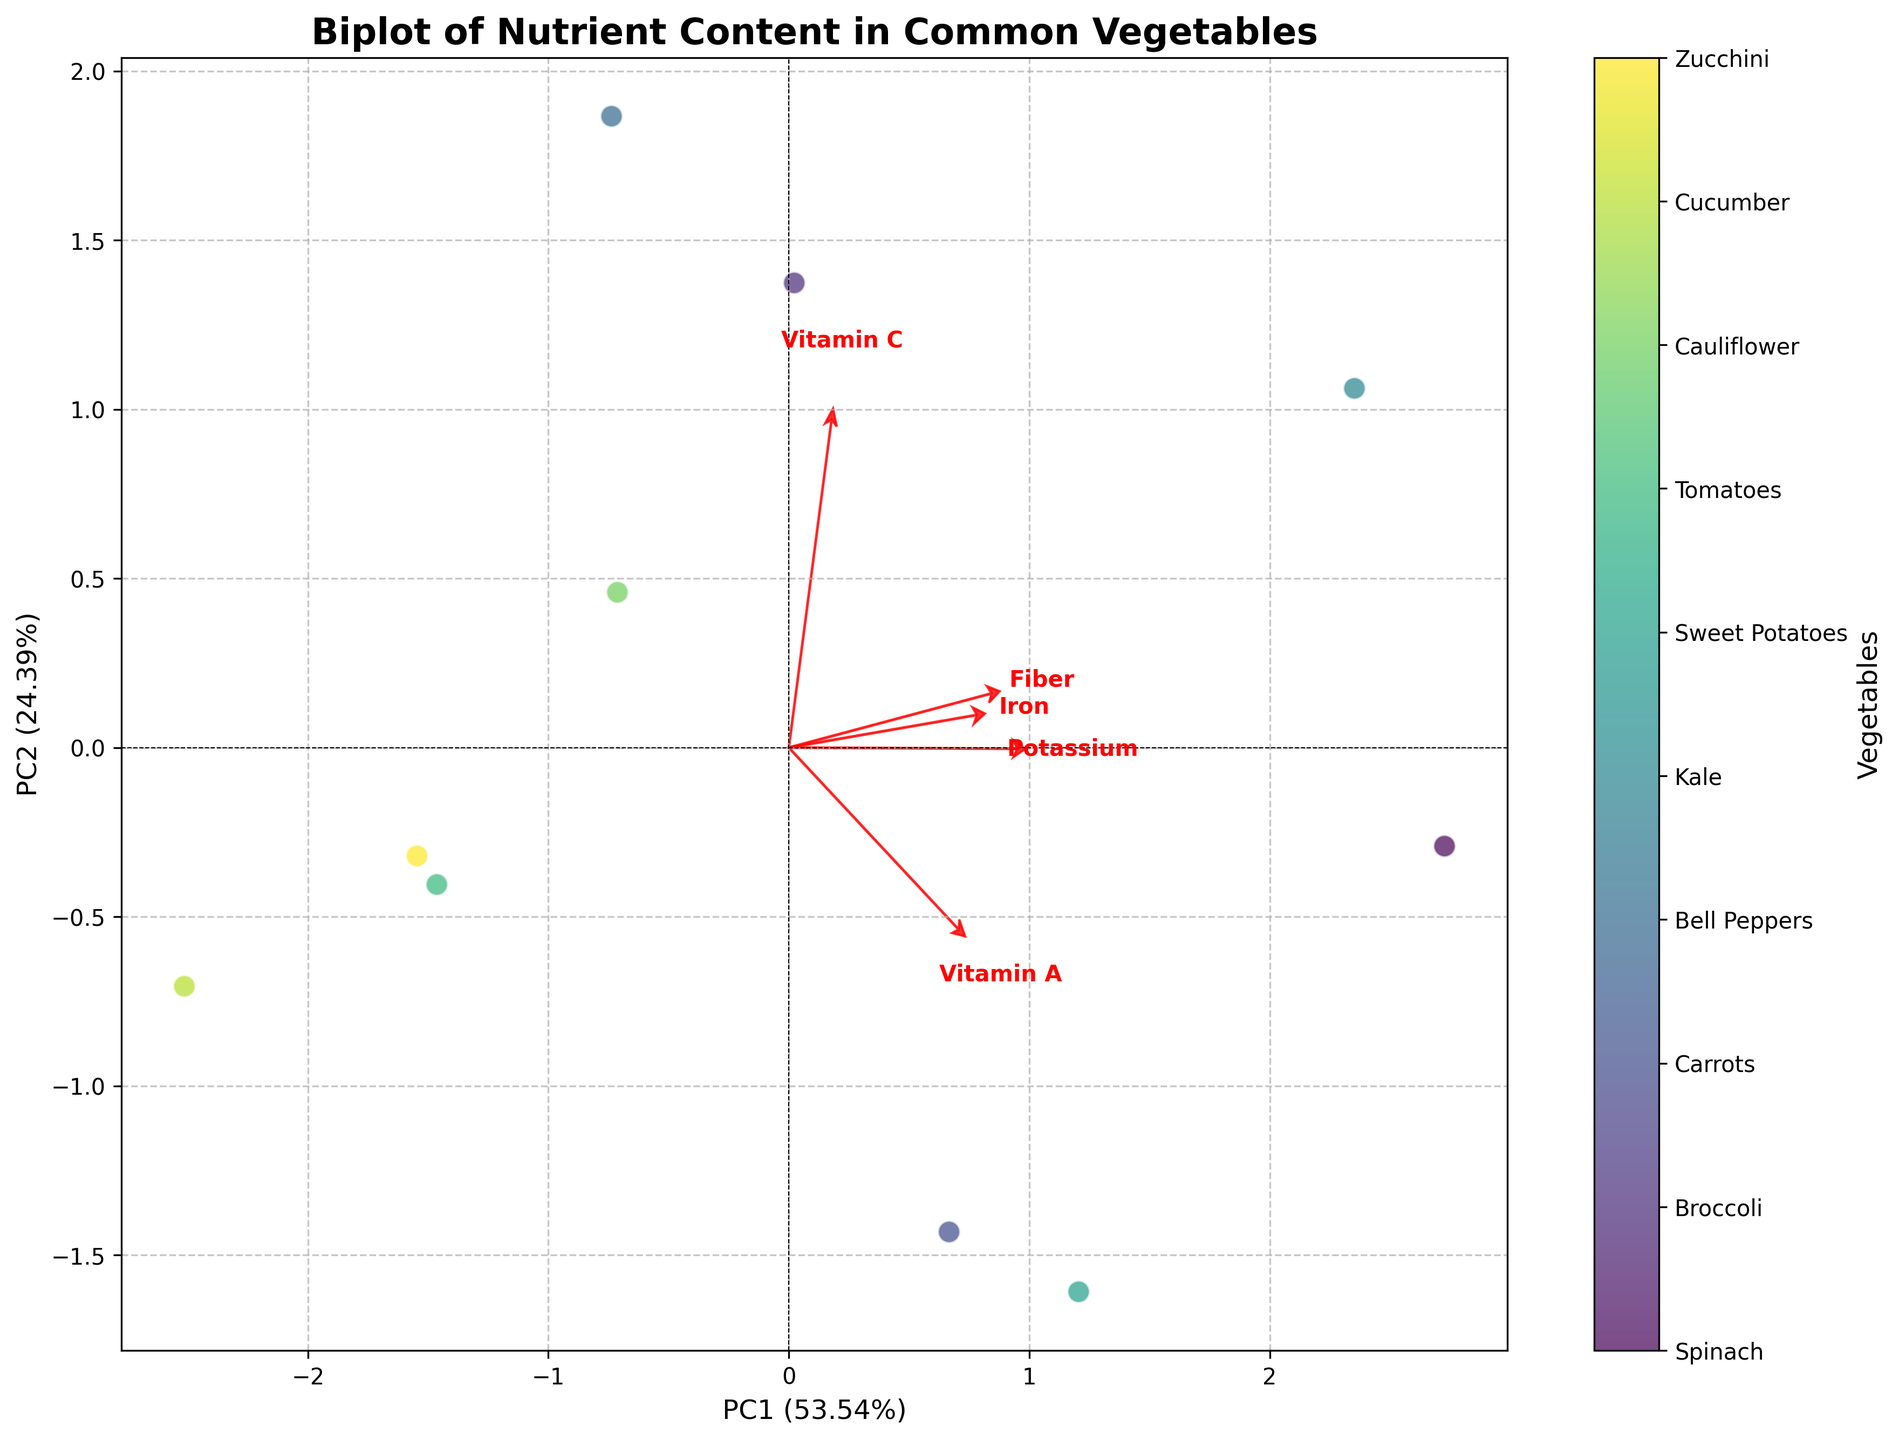What is the title of the figure? The title is usually found at the top of the figure. It gives a summary about what the figure represents, helping identify the context of the data visualization.
Answer: Biplot of Nutrient Content in Common Vegetables How many vegetables are included in the plot? To find the number of vegetables, count the distinct data points plotted on the graph. Each point represents a different vegetable.
Answer: 10 Which vegetable has the highest representation on the first principal component? Look for the data point that is the farthest along the horizontal axis (PC1). This point will represent the vegetable with the highest representation on the first principal component.
Answer: Bell Peppers How much variance is explained by PC1 and PC2 combined? Look at the axis labels where the variance explained by each principal component is indicated in percentage. Add the percentages of both PC1 and PC2 to get the combined variance.
Answer: Approximately 100% Which vegetables are located closely together in the plot, suggesting similar nutrient profiles? Observe the clustering of data points. Vegetables that are closer to each other on the plot suggest they have similar nutrient profiles.
Answer: Tomatoes and Zucchini What nutrient vector is the longest, indicating the greatest variance among vegetables? The length of the nutrient vectors represents the variance of that nutrient among all the vegetables. The longest vector corresponds to the nutrient with the greatest variance.
Answer: Vitamin A How do the loadings of Vitamin C and Fiber compare along the first and second principal components? Look at the directions and lengths of the Vitamin C and Fiber vectors along both axes (PC1 and PC2). This will show their loadings on these principal components.
Answer: Vitamin C has a strong positive loading on PC1 and a negative loading on PC2, whereas Fiber has a moderate positive loading on both PCs Which nutrient vector closely aligns with the second principal component? Identify which arrow (nutrient vector) is most aligned with the vertical axis (PC2). This indicates it has the highest loading on the second principal component.
Answer: Fiber Which vegetable is most associated with high Vitamin A content based on the plot? Find the eigenvector for Vitamin A and trace the direction it points from the origin. Look for the vegetable data point closest to the end of this vector, indicating it has a high Vitamin A content.
Answer: Sweet Potatoes Based on the loadings, which nutrients show a positive correlation? Look at the angles between the nutrient vectors. Vectors pointing in similar directions indicate positive correlation.
Answer: Vitamin A and Vitamin C Which vegetable appears to be rich in both Potassium and Iron? Identify which data point lies in the same direction as the eigenvectors for Potassium and Iron suggesting high loadings for both these nutrients.
Answer: Spinach 